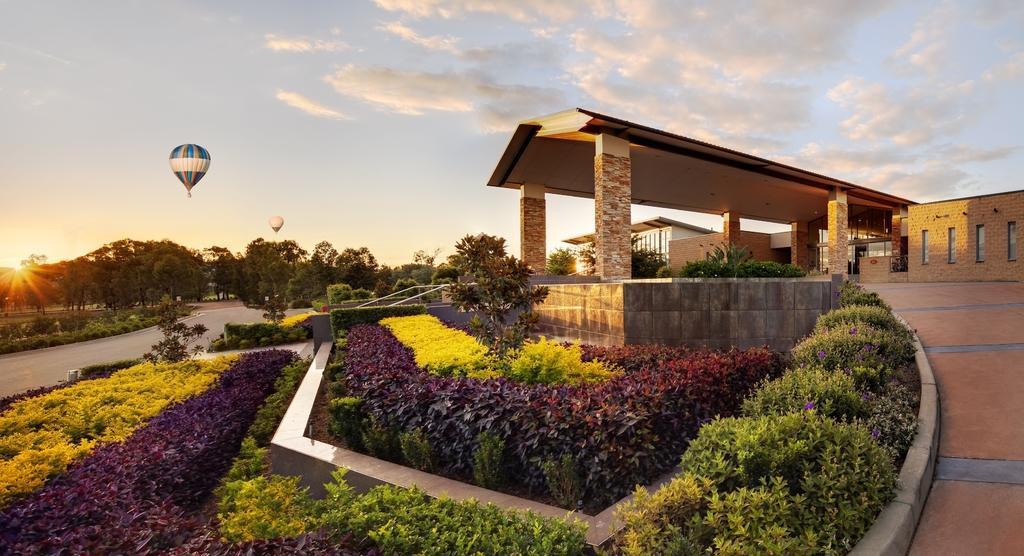How would you summarize this image in a sentence or two? In this picture I can see some buildings, plants, trees and I can see sun in the sky. 